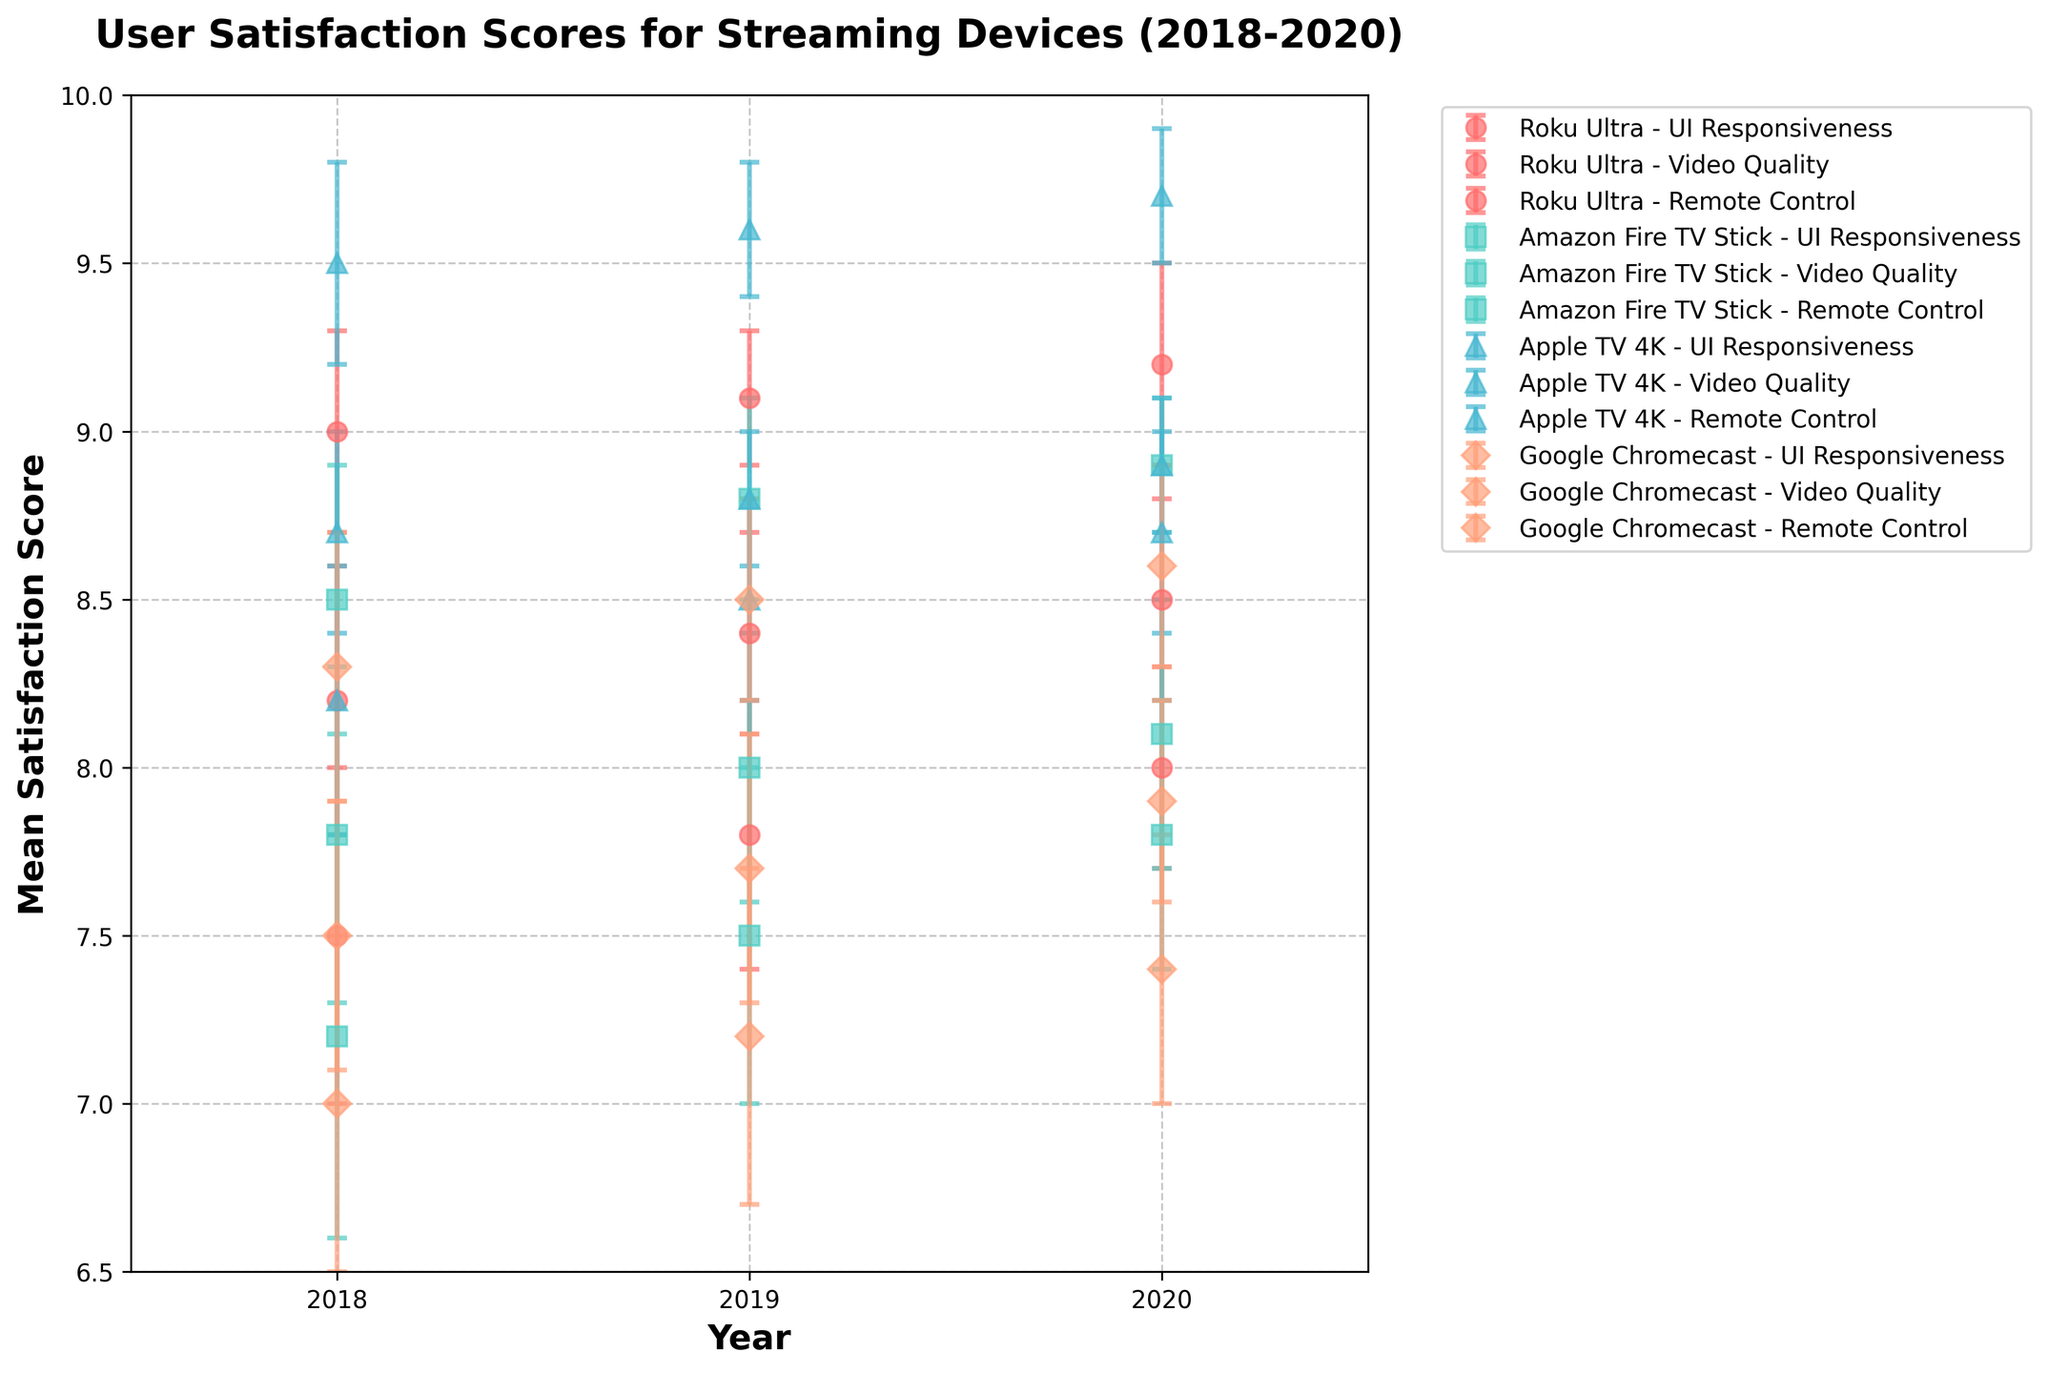What’s the title of the figure? Look at the top of the figure where the title is usually located. The title reads "User Satisfaction Scores for Streaming Devices (2018-2020)".
Answer: User Satisfaction Scores for Streaming Devices (2018-2020) What are the x-axis and y-axis labels? The x-axis label is "Year" and the y-axis label is "Mean Satisfaction Score", found along the horizontal and vertical axes respectively.
Answer: Year, Mean Satisfaction Score Which device has the highest mean satisfaction score for Remote Control in 2018? Find the scores for Remote Control in 2018 and identify the highest one. Apple TV 4K has the highest score of 8.2.
Answer: Apple TV 4K Which feature of Roku Ultra witnessed the greatest increase in user satisfaction from 2018 to 2020? Check the differences between the scores in 2018 and 2020 for each feature of Roku Ultra. UI Responsiveness increased from 8.2 to 8.5 (0.3), Video Quality from 9.0 to 9.2 (0.2), and Remote Control from 7.5 to 8.0 (0.5). Thus, Remote Control saw the greatest increase.
Answer: Remote Control Between 2018 and 2020, did the mean satisfaction score for Video Quality of Google Chromecast increase or decrease? Analyze Google Chromecast's Video Quality scores over the years: 8.3 (2018), 8.5 (2019), 8.6 (2020). There was an increase.
Answer: Increase Which device had the lowest mean satisfaction score in any given year and feature? Compare all scores and find the lowest. Google Chromecast's Remote Control feature in 2018 has the lowest score of 7.0.
Answer: Google Chromecast What is the error range for Amazon Fire TV Stick’s Video Quality in 2020? Locate Amazon Fire TV Stick's Video Quality in 2020 and see the error bars. It’s shown as 8.9 ± 0.2, so the range is 8.7 to 9.1.
Answer: 8.7 to 9.1 Which device shows the most consistent satisfaction scores across all features from 2018 to 2020? Evaluate each device by examining the variation (or consistency) of their scores. Apple TV 4K displays the most consistent high scores, with small changes over time.
Answer: Apple TV 4K 